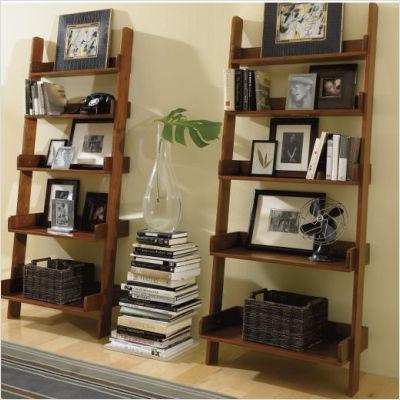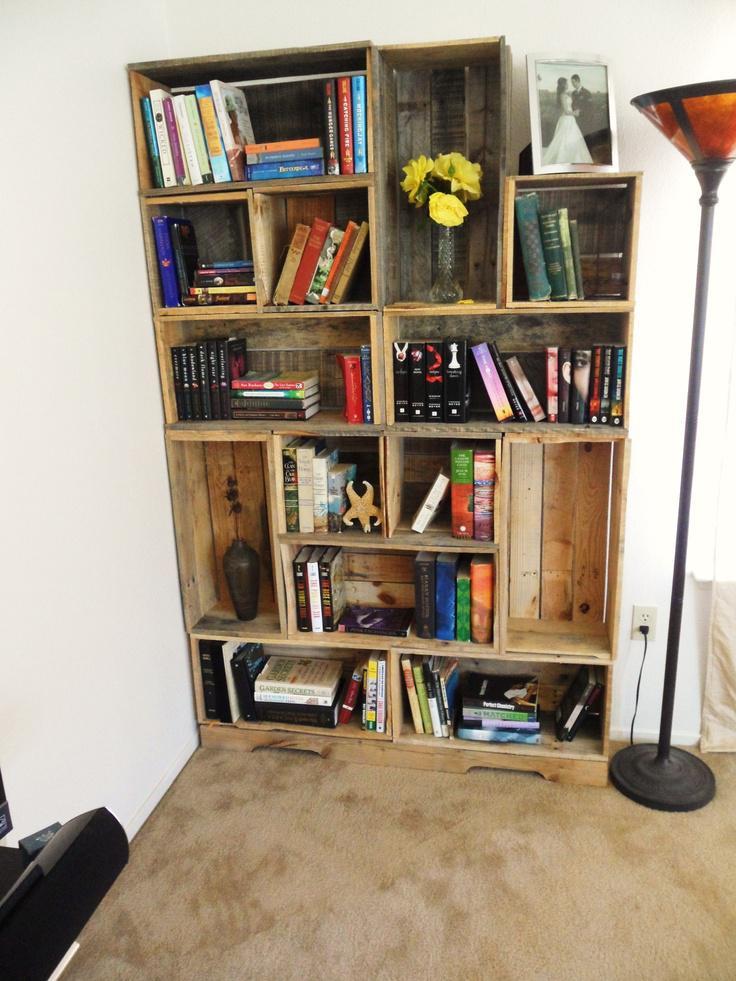The first image is the image on the left, the second image is the image on the right. Analyze the images presented: Is the assertion "There are at least three bookshelves made in to one that take up the wall of a room." valid? Answer yes or no. No. 